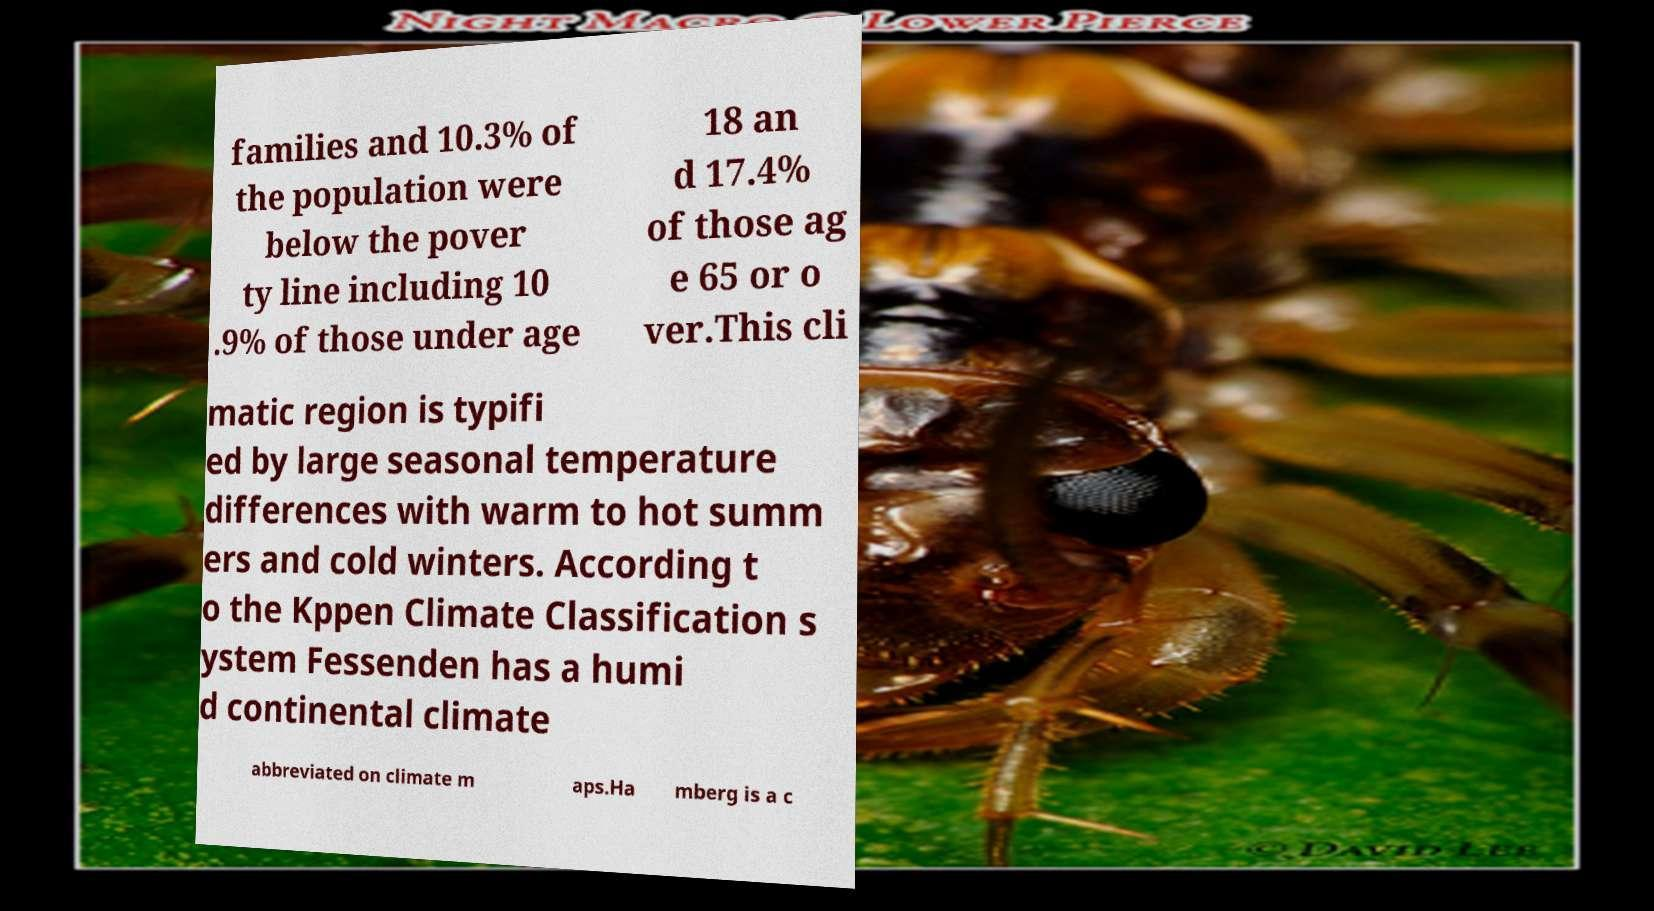Can you accurately transcribe the text from the provided image for me? families and 10.3% of the population were below the pover ty line including 10 .9% of those under age 18 an d 17.4% of those ag e 65 or o ver.This cli matic region is typifi ed by large seasonal temperature differences with warm to hot summ ers and cold winters. According t o the Kppen Climate Classification s ystem Fessenden has a humi d continental climate abbreviated on climate m aps.Ha mberg is a c 